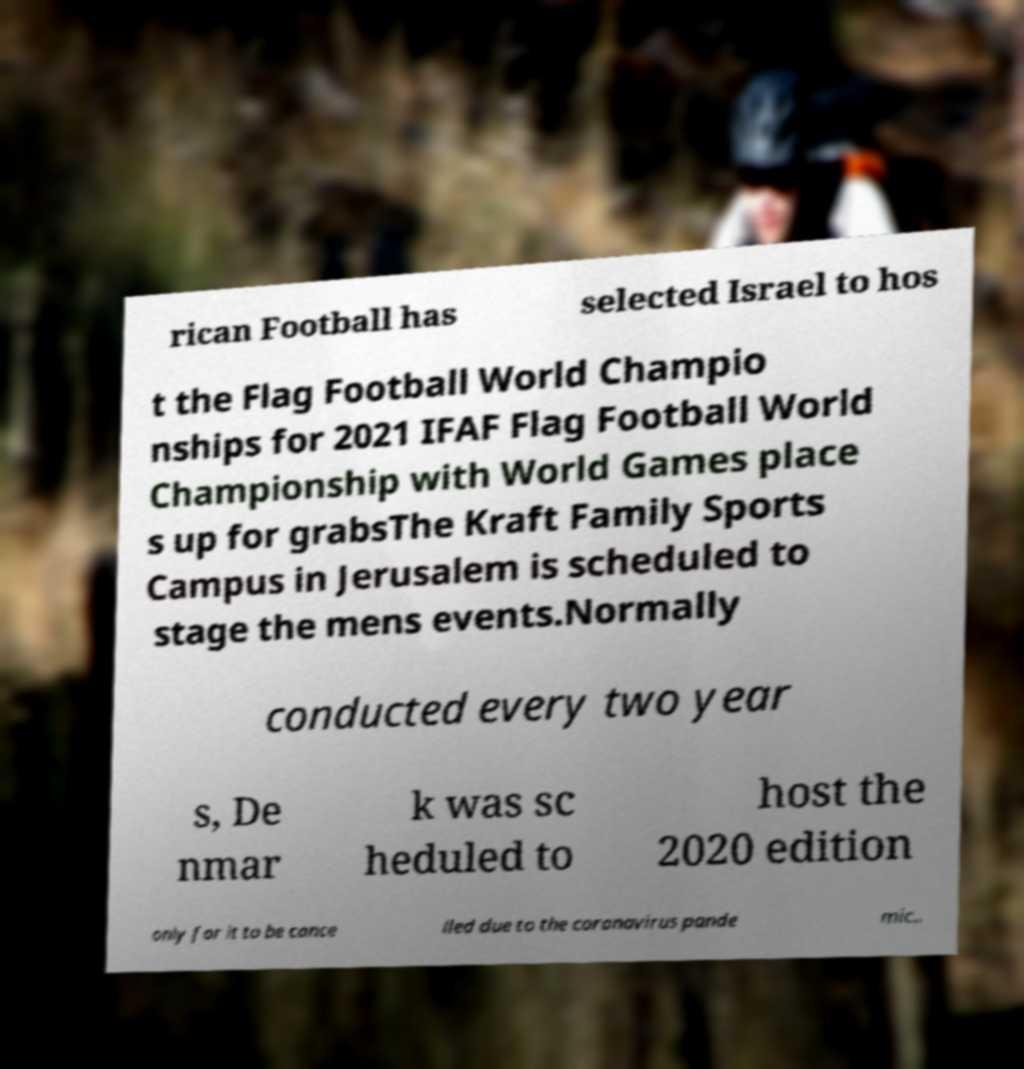Could you assist in decoding the text presented in this image and type it out clearly? rican Football has selected Israel to hos t the Flag Football World Champio nships for 2021 IFAF Flag Football World Championship with World Games place s up for grabsThe Kraft Family Sports Campus in Jerusalem is scheduled to stage the mens events.Normally conducted every two year s, De nmar k was sc heduled to host the 2020 edition only for it to be cance lled due to the coronavirus pande mic.. 